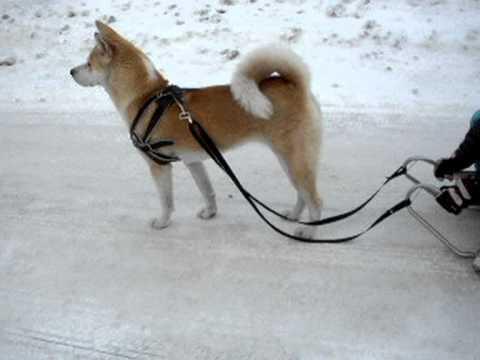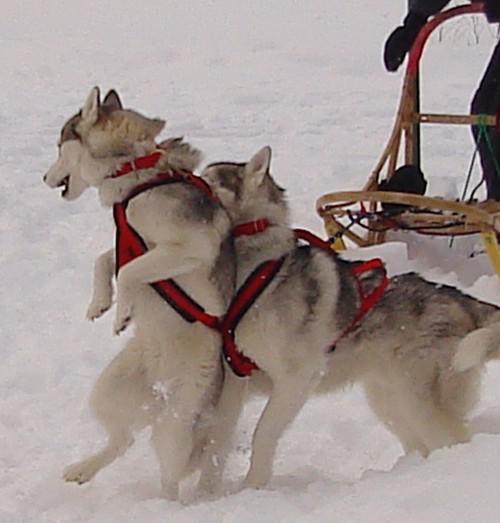The first image is the image on the left, the second image is the image on the right. Considering the images on both sides, is "There are two huskies in red harness standing on the snow." valid? Answer yes or no. Yes. The first image is the image on the left, the second image is the image on the right. For the images shown, is this caption "Some dogs are moving forward." true? Answer yes or no. No. 